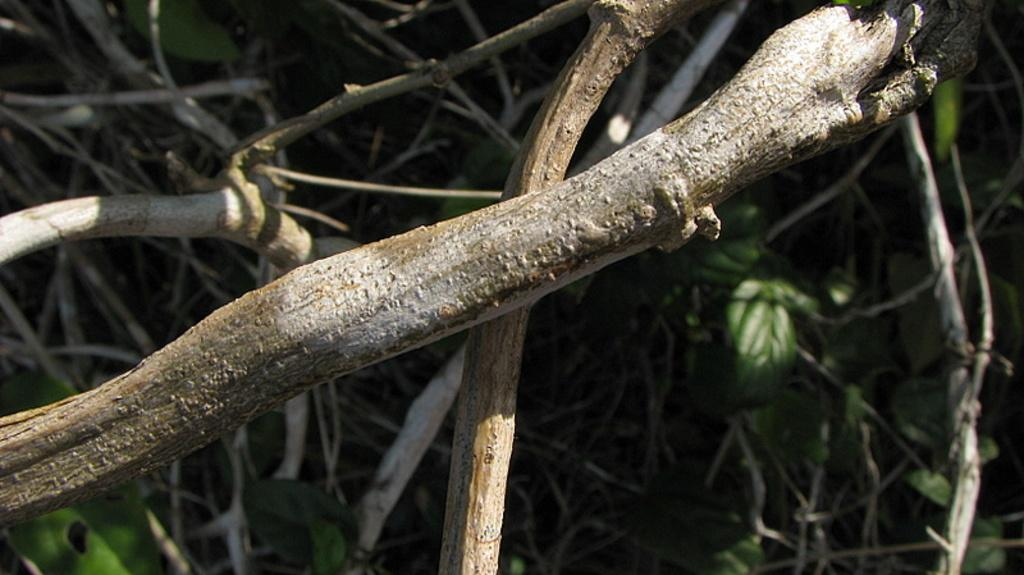What is the main subject of the picture? The main subject of the picture is the branches of a tree. Can you describe the background of the image? The background of the image is blurred. What type of shoes are being discussed in the image? There is no discussion or mention of shoes in the image; it features branches of a tree and a blurred background. 